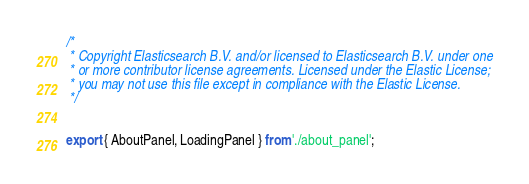<code> <loc_0><loc_0><loc_500><loc_500><_JavaScript_>/*
 * Copyright Elasticsearch B.V. and/or licensed to Elasticsearch B.V. under one
 * or more contributor license agreements. Licensed under the Elastic License;
 * you may not use this file except in compliance with the Elastic License.
 */


export { AboutPanel, LoadingPanel } from './about_panel';
</code> 